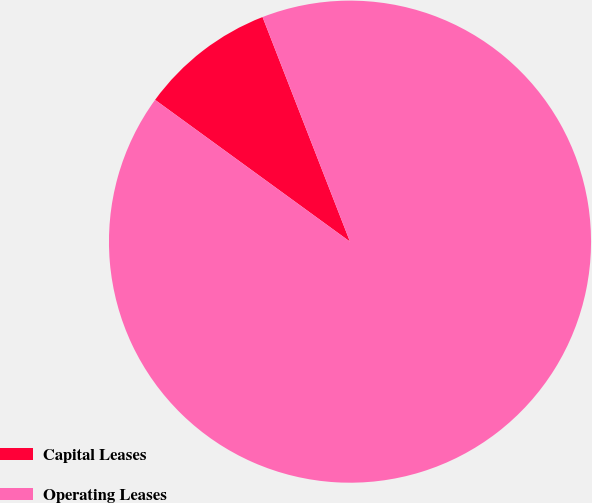Convert chart to OTSL. <chart><loc_0><loc_0><loc_500><loc_500><pie_chart><fcel>Capital Leases<fcel>Operating Leases<nl><fcel>9.08%<fcel>90.92%<nl></chart> 